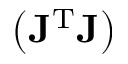<formula> <loc_0><loc_0><loc_500><loc_500>\left ( J ^ { T } J \right )</formula> 